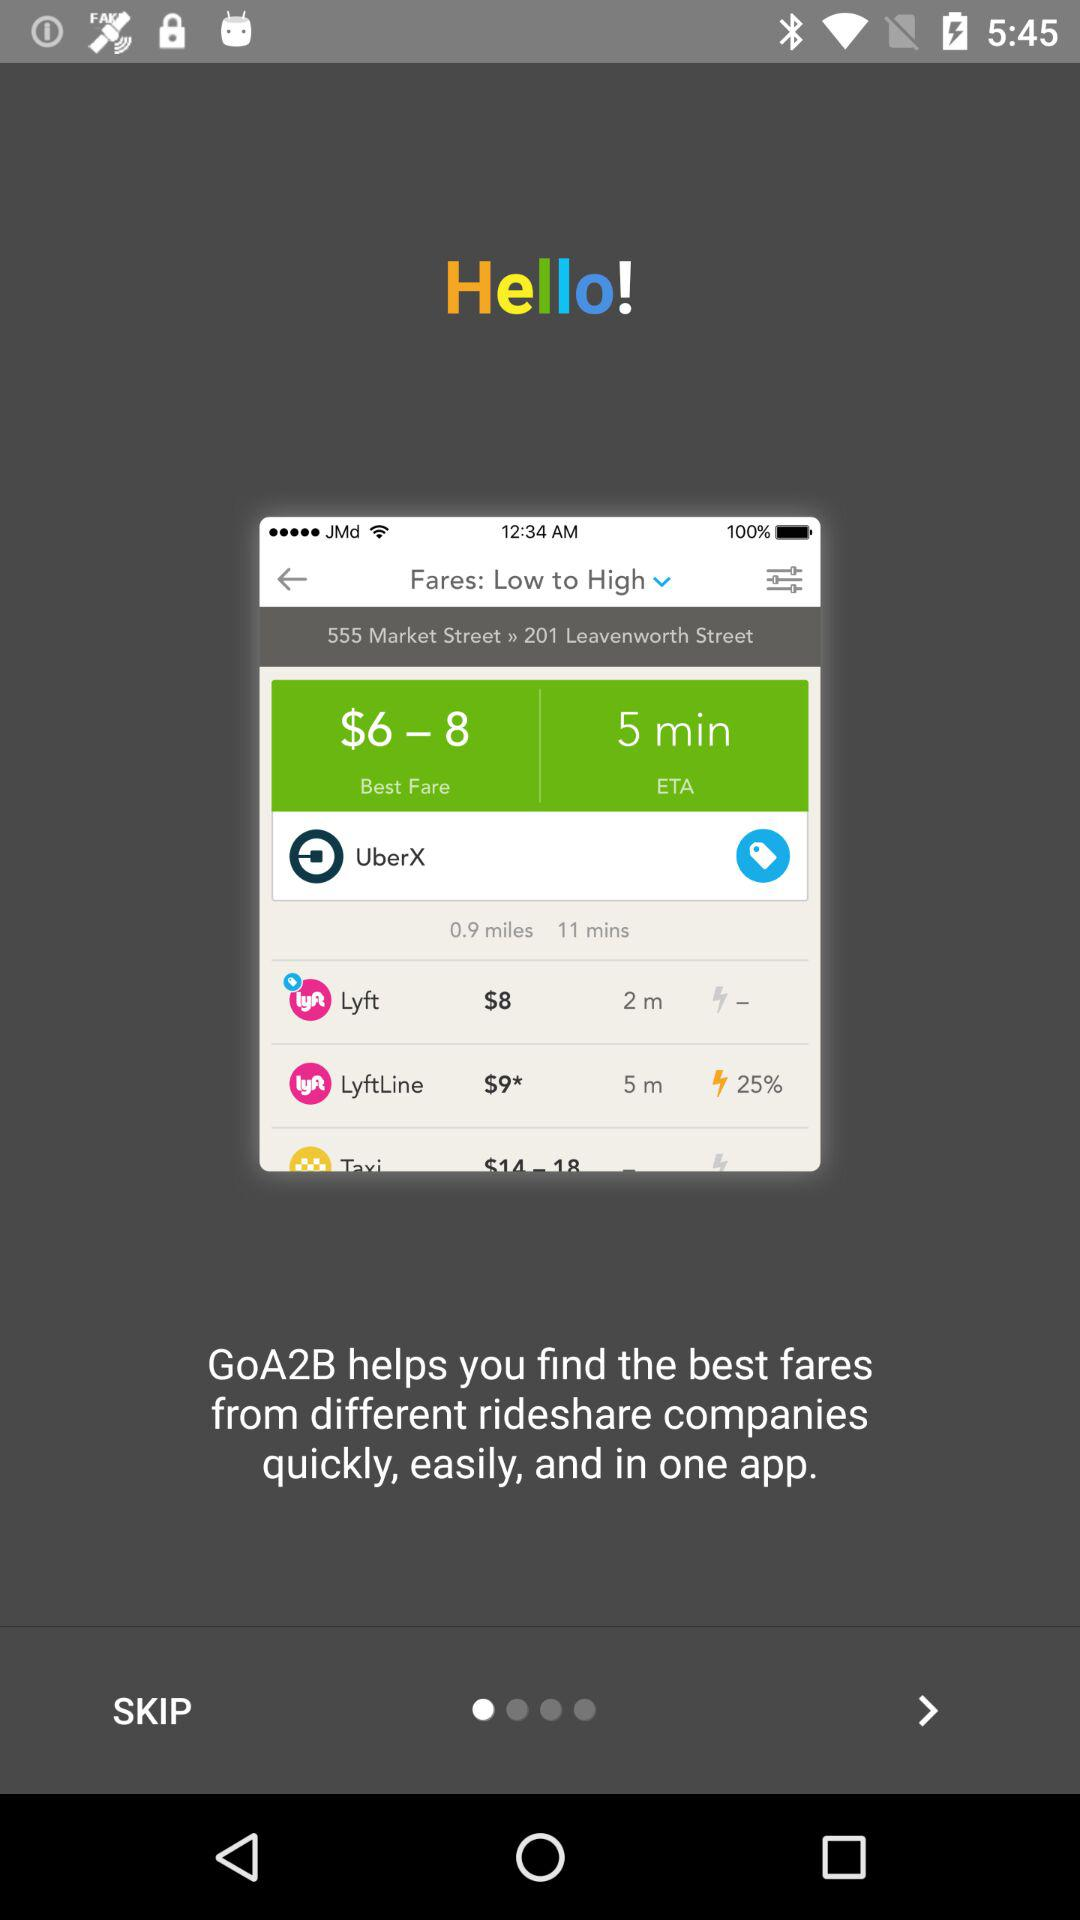What is the best fare? The best fare ranges from $6 to $8. 